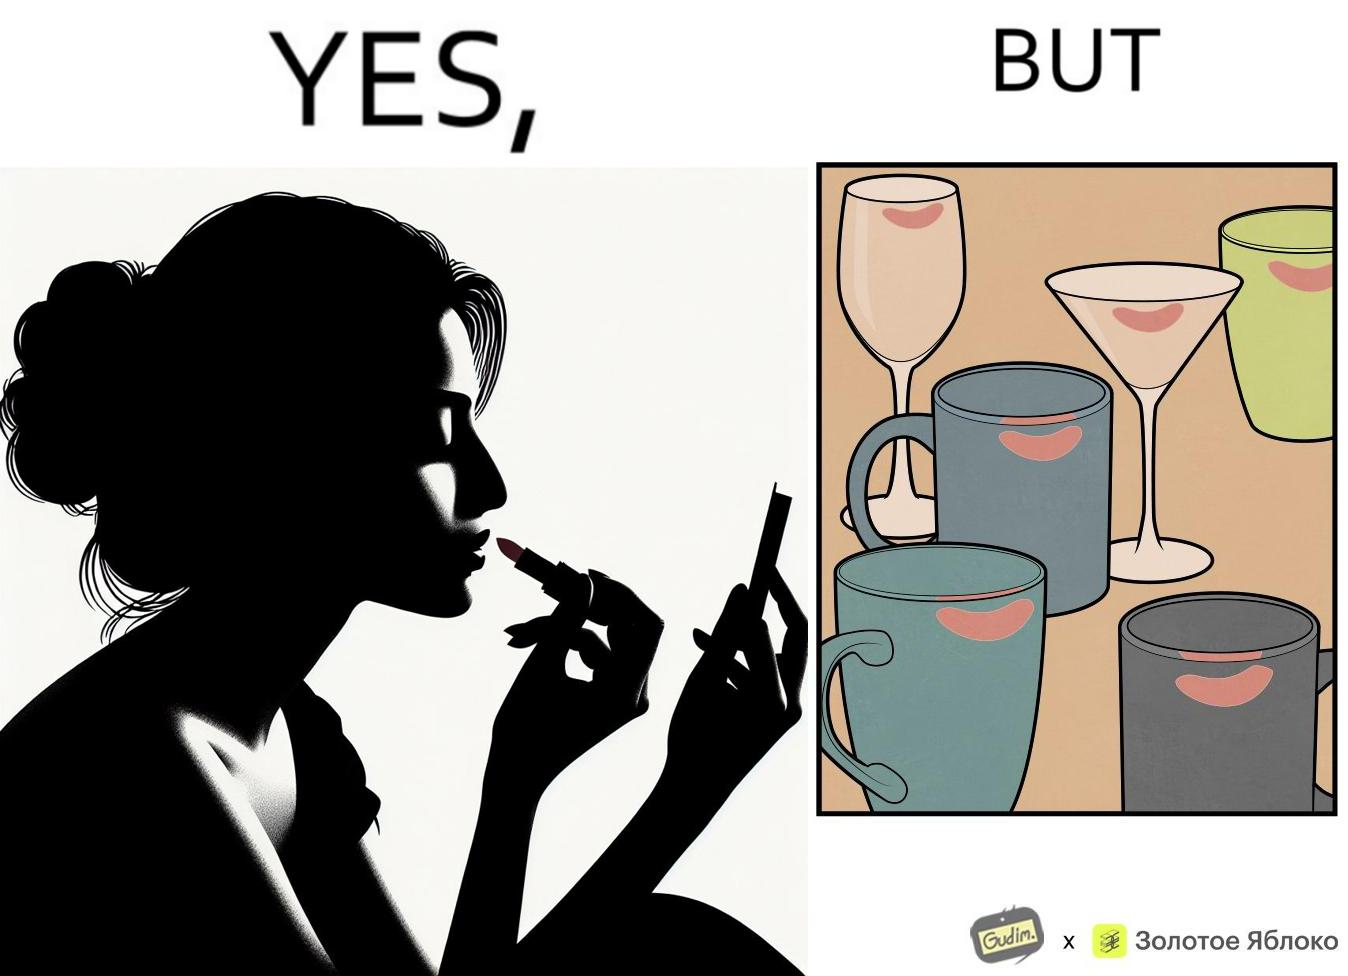Provide a description of this image. The image is ironic, because the left image suggest that a person applies lipsticks on their lips to make their lips look attractive or to keep them hydrated but on the contrary it gets sticked to the glasses or mugs and gets wasted 